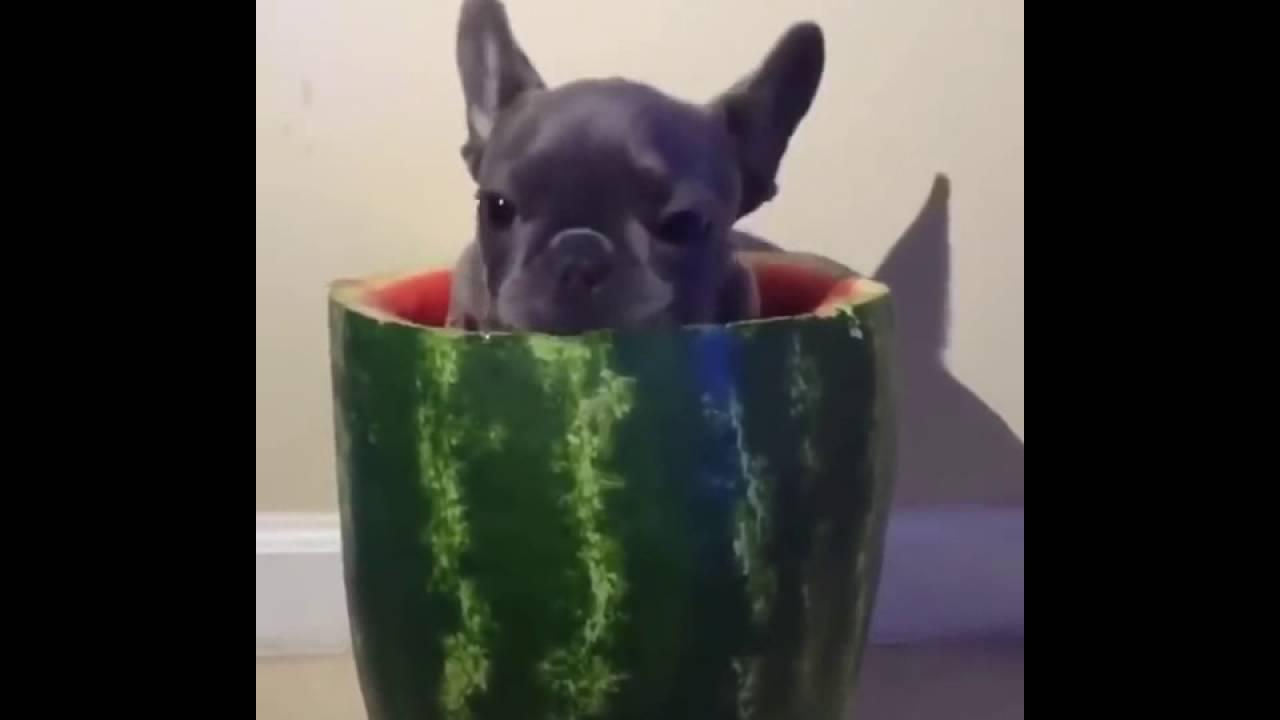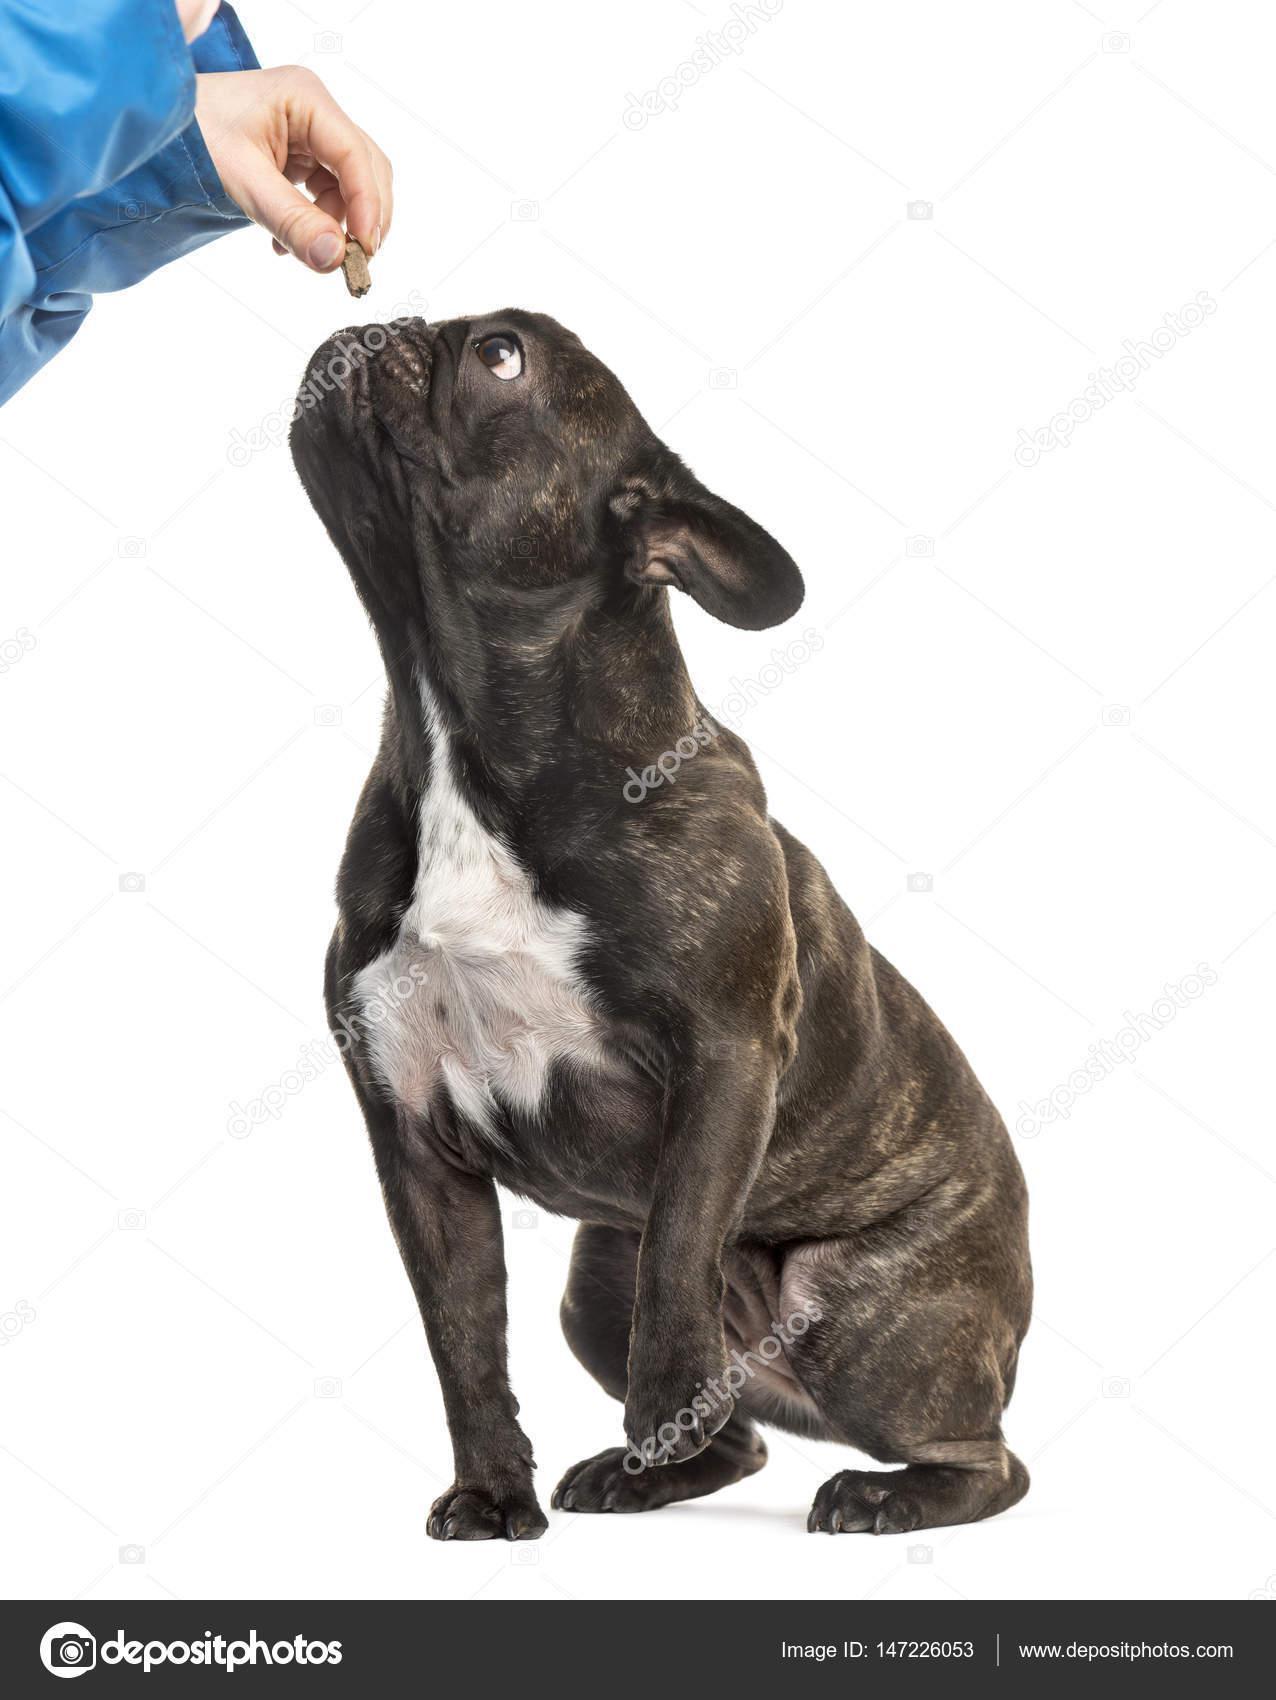The first image is the image on the left, the second image is the image on the right. Examine the images to the left and right. Is the description "One image in the pair shows at least one dog eating." accurate? Answer yes or no. No. The first image is the image on the left, the second image is the image on the right. Considering the images on both sides, is "One image features a french bulldog wearing a checkered napkin around its neck, and the other image includes a silver-colored dog food bowl and at least one bulldog." valid? Answer yes or no. No. 